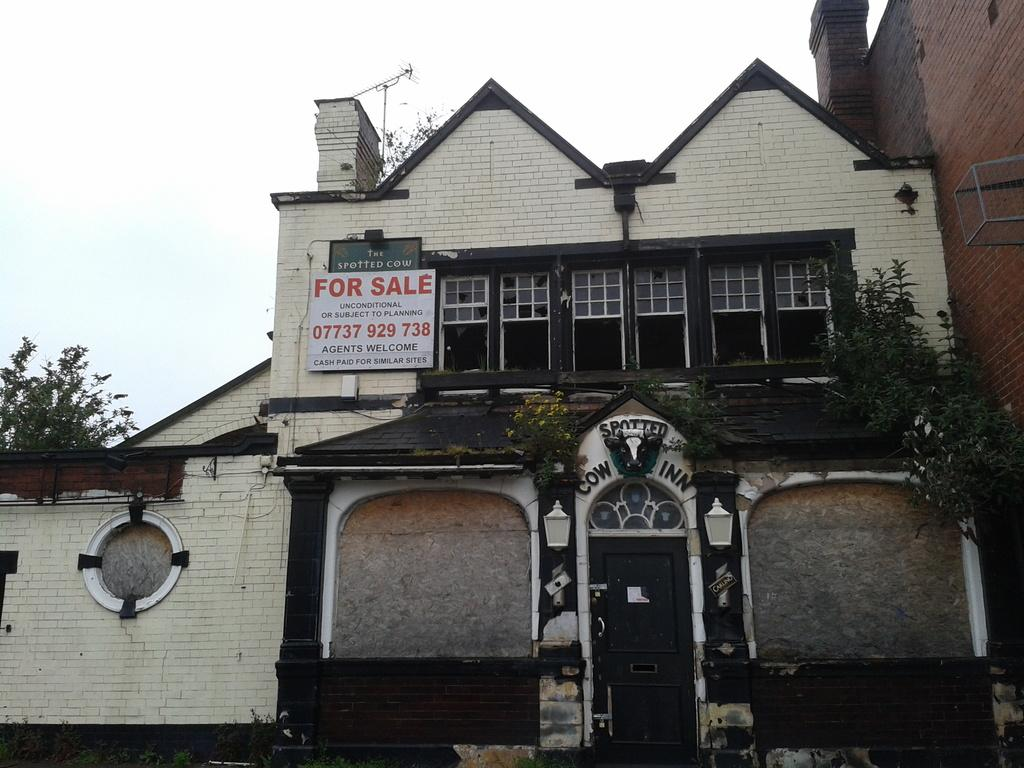What type of structure is visible in the image? There is a building in the image. What features can be seen on the building? The building has windows, a door, plants, and a board. What is written on the board on the building? Something is written on the board, but the specific message cannot be determined from the image. What is visible in the background of the image? The sky is visible in the background of the image. How many pies are being sold by the jellyfish on the road in the image? There are no pies, jellyfish, or roads present in the image. 